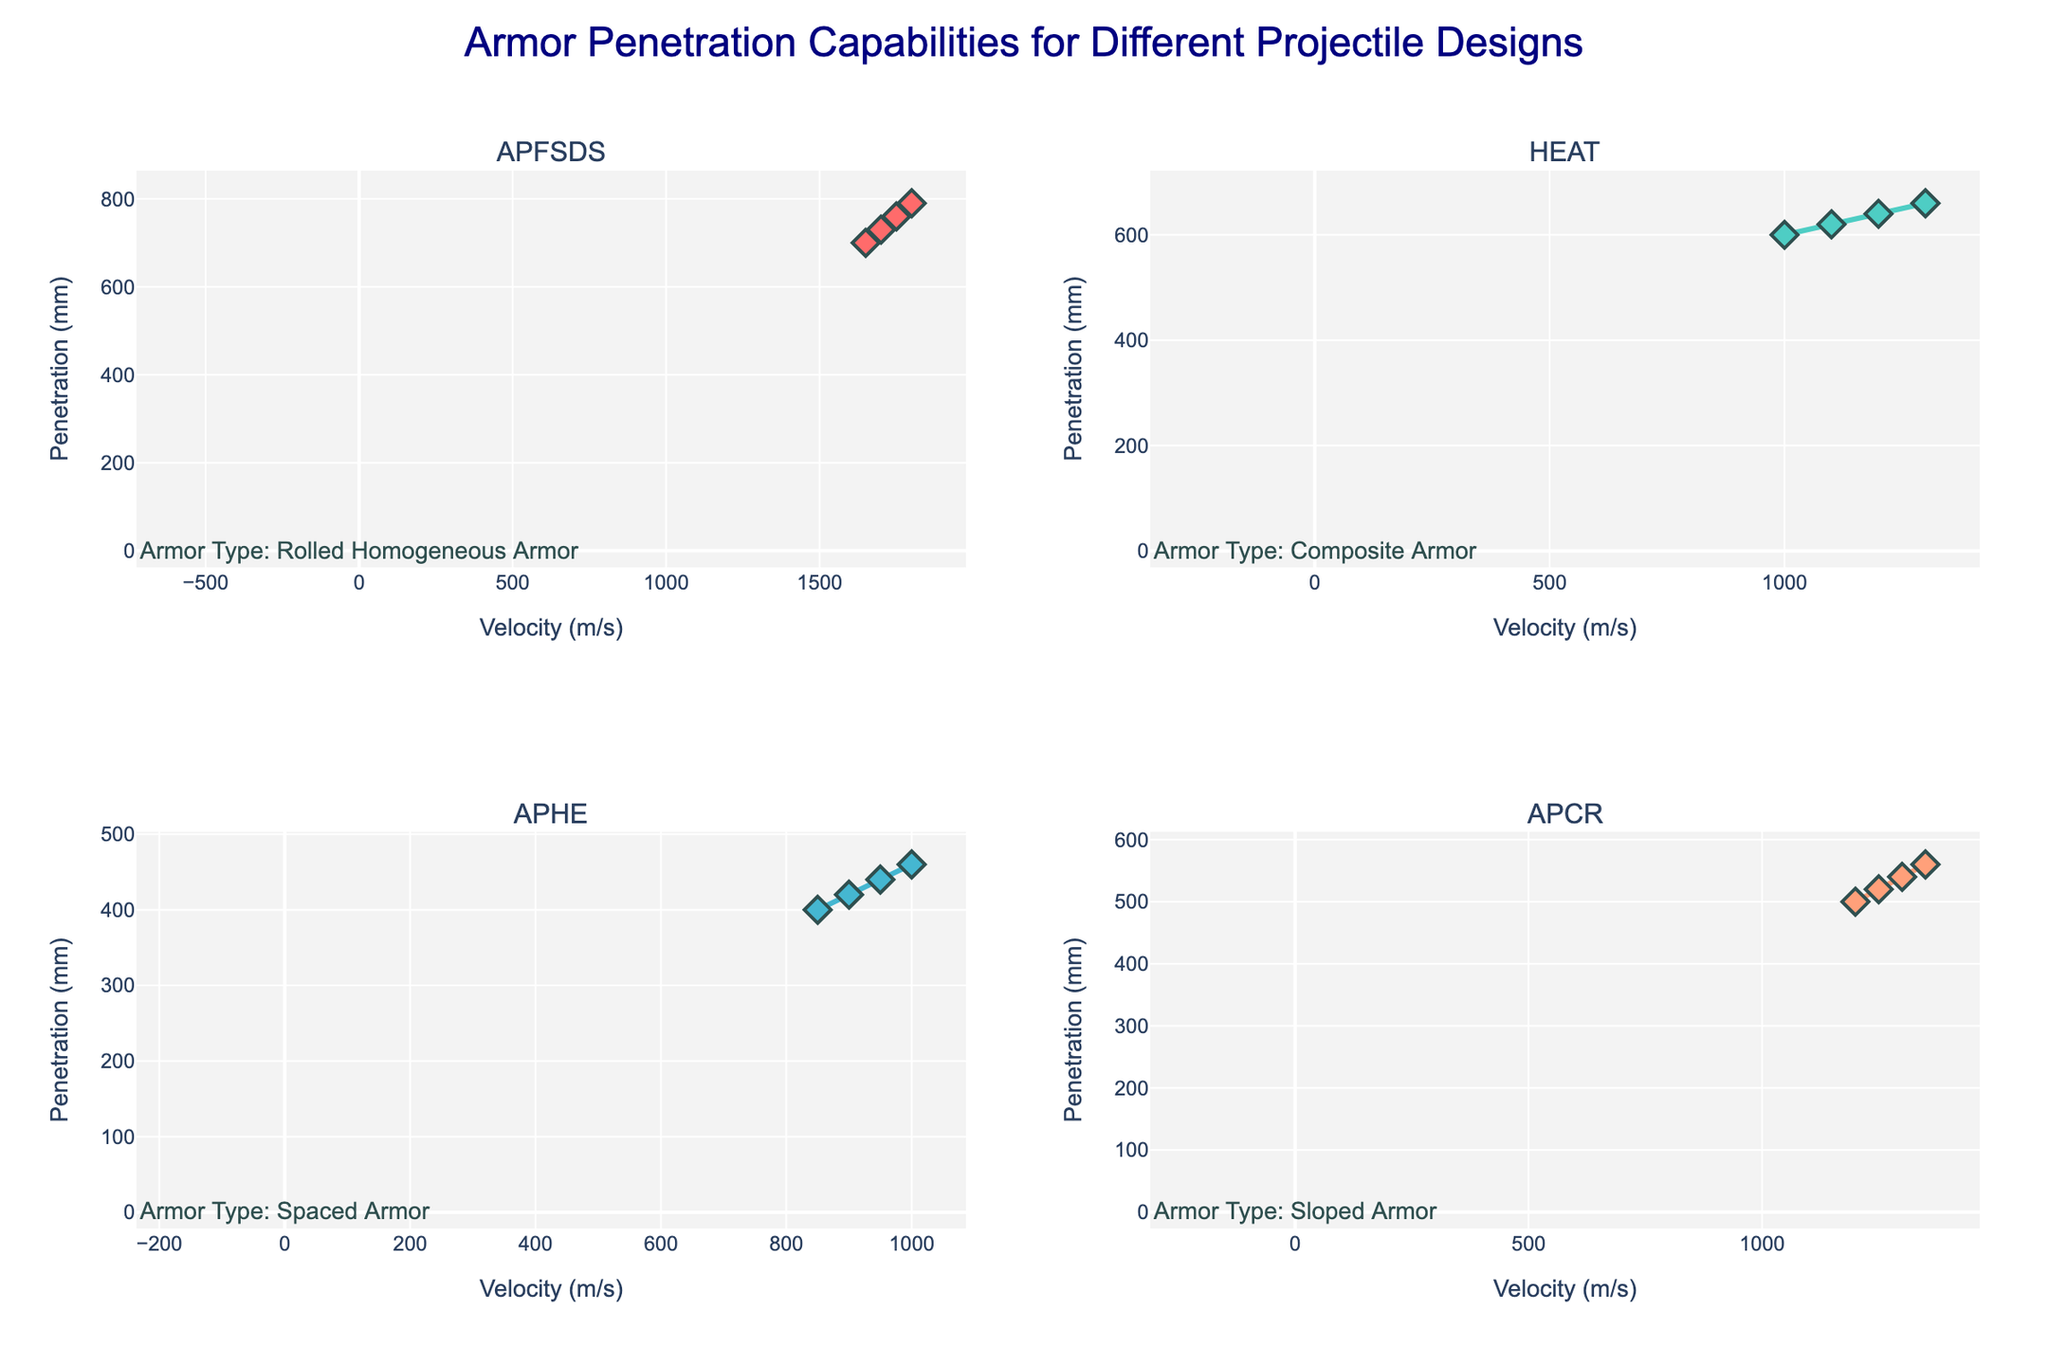What is the title of the figure? The title of the figure is located at the top center of the plot. By looking at the figure, we can see it says "Armor Penetration Capabilities for Different Projectile Designs".
Answer: Armor Penetration Capabilities for Different Projectile Designs What is the axis title for the x-axis in the subplot for APFSDS projectiles? By examining the subplot for APFSDS (top-left corner), we find the x-axis title. It reads "Velocity (m/s)".
Answer: Velocity (m/s) How many data points are plotted for the HEAT projectiles? In the second subplot (top-right corner) for HEAT projectiles, counting the markers on the graph shows a total of 4 data points.
Answer: 4 Which projectile type is tested against Sloped Armor? By looking at the subplots and the annotations indicating the armor type, we see that APCR projectiles (bottom-right subplot) are tested against Sloped Armor.
Answer: APCR Which projectile type shows the highest penetration depth and what is the value? To determine the highest penetration depth, examine the plots and find the maximum y-value. The APFSDS projectile (top-left) shows the highest penetration depth of 790 mm.
Answer: APFSDS, 790 mm Which projectile type exhibits the steepest increase in penetration depth with increasing velocity? By comparing the slopes of the lines in each subplot, we observe that the APFSDS projectiles (top-left) have the steepest increase, indicated by the most rapid rise in penetration depth with increasing velocity.
Answer: APFSDS What is the maximum velocity tested for the APHE projectiles? By checking the x-axis values for the bottom-left subplot (APHE), we see the maximum velocity tested is 1000 m/s.
Answer: 1000 m/s What is the difference in penetration depth between the highest and lowest data points for APCR projectiles? In the bottom-right subplot, for APCR projectiles, the highest penetration is 560 mm and the lowest is 500 mm. The difference is 560 - 500 = 60 mm.
Answer: 60 mm Which projectile type has the lowest range of tested velocities? By looking at the range of x-axis values (velocities) in all subplots, HEAT projectiles (top-right) have the lowest range of 1000 to 1300 m/s, a range of 300 m/s.
Answer: HEAT What is the average penetration depth for HEAT projectiles? Summing the penetration values for HEAT (600, 620, 640, 660) gives 2520 mm. Dividing by the number of data points (4) results in an average penetration depth of 2520 / 4 = 630 mm.
Answer: 630 mm 